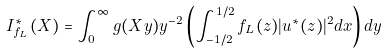Convert formula to latex. <formula><loc_0><loc_0><loc_500><loc_500>I ^ { \ast } _ { f _ { L } } ( X ) = \int ^ { \infty } _ { 0 } g ( X y ) y ^ { - 2 } \left ( \int ^ { 1 / 2 } _ { - 1 / 2 } f _ { L } ( z ) | u ^ { \ast } ( z ) | ^ { 2 } d x \right ) d y</formula> 